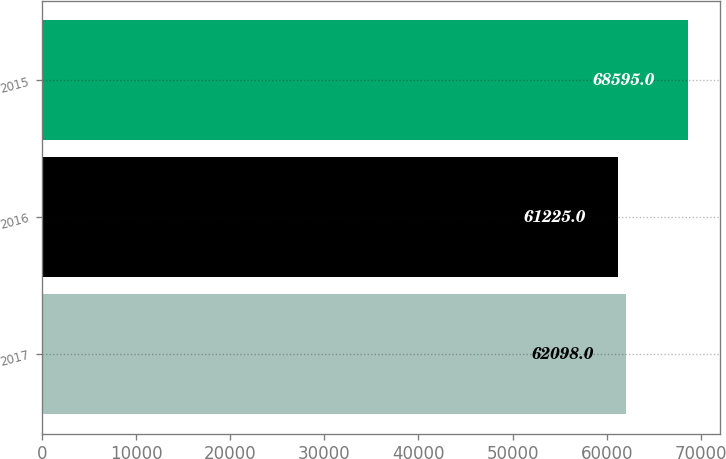Convert chart to OTSL. <chart><loc_0><loc_0><loc_500><loc_500><bar_chart><fcel>2017<fcel>2016<fcel>2015<nl><fcel>62098<fcel>61225<fcel>68595<nl></chart> 